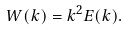Convert formula to latex. <formula><loc_0><loc_0><loc_500><loc_500>W ( k ) = k ^ { 2 } E ( k ) .</formula> 